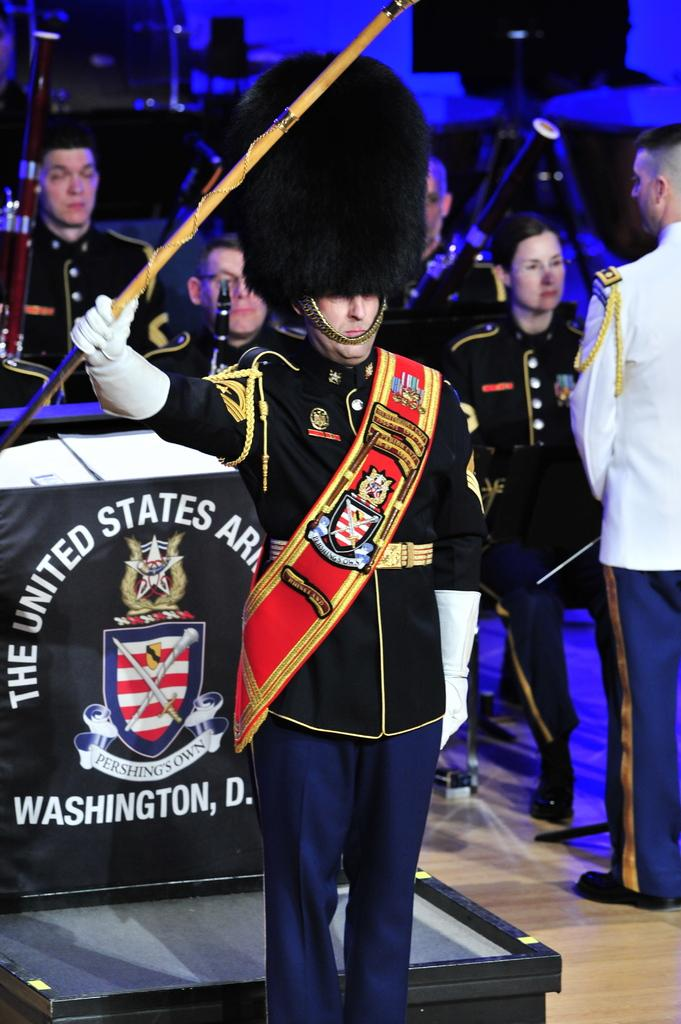What is the main subject of the image? There is a person in a costume in the image. What is the person in the costume holding? The person is holding a stick in his hand. What can be seen in the background of the image? There are people visible in the background of the image, and there is a poster with text. How many books are visible in the image? There are no books visible in the image. Is there a tent in the image? There is no tent present in the image. 